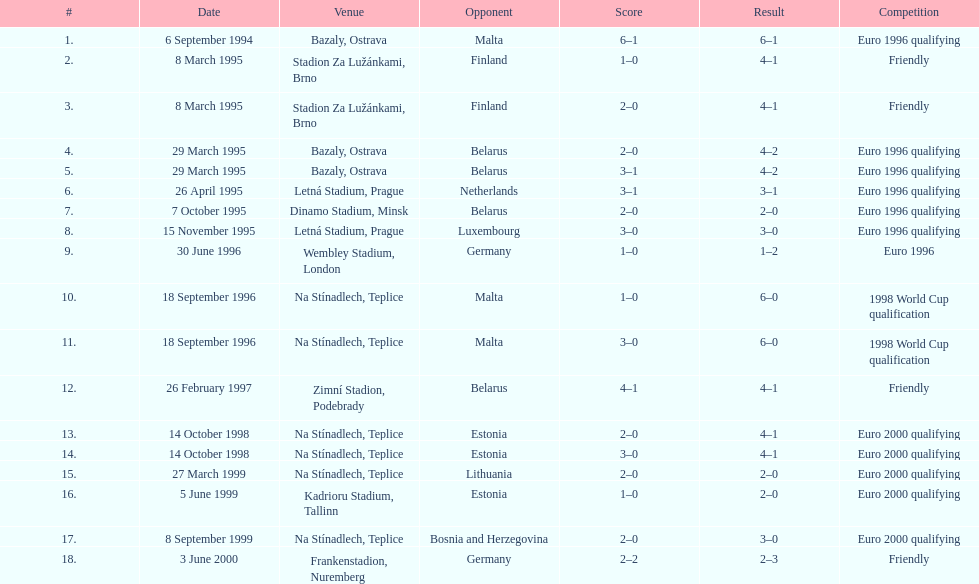Who is the final opponent mentioned in the table? Germany. 